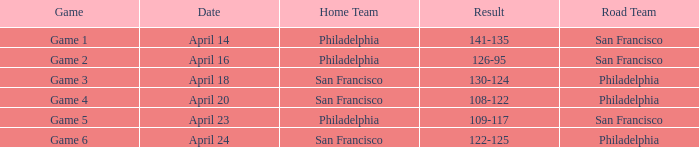What was the result of the April 16 game? 126-95. 